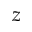Convert formula to latex. <formula><loc_0><loc_0><loc_500><loc_500>z</formula> 